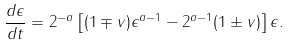<formula> <loc_0><loc_0><loc_500><loc_500>\frac { d \epsilon } { d t } = 2 ^ { - a } \left [ ( 1 \mp v ) \epsilon ^ { a - 1 } - 2 ^ { a - 1 } ( 1 \pm v ) \right ] \epsilon .</formula> 